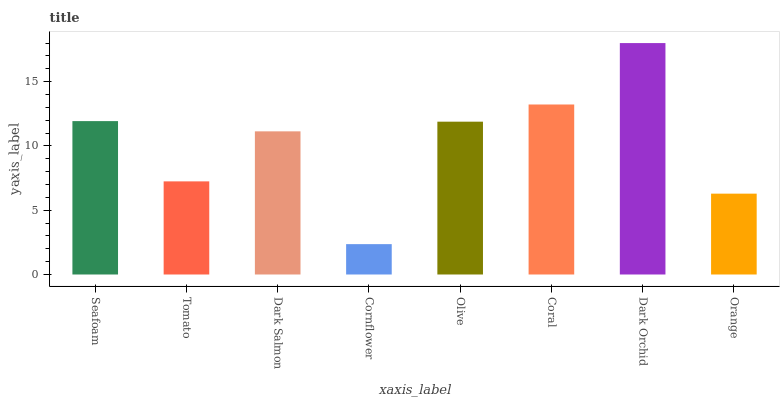Is Cornflower the minimum?
Answer yes or no. Yes. Is Dark Orchid the maximum?
Answer yes or no. Yes. Is Tomato the minimum?
Answer yes or no. No. Is Tomato the maximum?
Answer yes or no. No. Is Seafoam greater than Tomato?
Answer yes or no. Yes. Is Tomato less than Seafoam?
Answer yes or no. Yes. Is Tomato greater than Seafoam?
Answer yes or no. No. Is Seafoam less than Tomato?
Answer yes or no. No. Is Olive the high median?
Answer yes or no. Yes. Is Dark Salmon the low median?
Answer yes or no. Yes. Is Coral the high median?
Answer yes or no. No. Is Cornflower the low median?
Answer yes or no. No. 